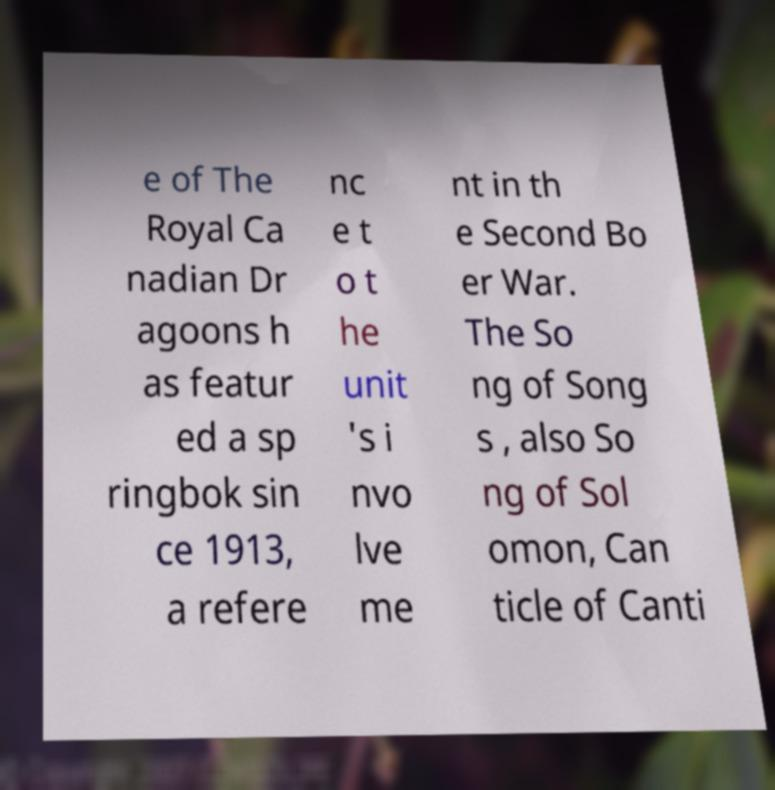What messages or text are displayed in this image? I need them in a readable, typed format. e of The Royal Ca nadian Dr agoons h as featur ed a sp ringbok sin ce 1913, a refere nc e t o t he unit 's i nvo lve me nt in th e Second Bo er War. The So ng of Song s , also So ng of Sol omon, Can ticle of Canti 